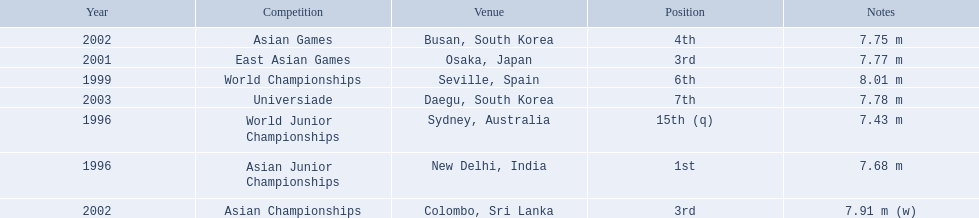Can you give me this table in json format? {'header': ['Year', 'Competition', 'Venue', 'Position', 'Notes'], 'rows': [['2002', 'Asian Games', 'Busan, South Korea', '4th', '7.75 m'], ['2001', 'East Asian Games', 'Osaka, Japan', '3rd', '7.77 m'], ['1999', 'World Championships', 'Seville, Spain', '6th', '8.01 m'], ['2003', 'Universiade', 'Daegu, South Korea', '7th', '7.78 m'], ['1996', 'World Junior Championships', 'Sydney, Australia', '15th (q)', '7.43 m'], ['1996', 'Asian Junior Championships', 'New Delhi, India', '1st', '7.68 m'], ['2002', 'Asian Championships', 'Colombo, Sri Lanka', '3rd', '7.91 m (w)']]} What are all of the competitions? World Junior Championships, Asian Junior Championships, World Championships, East Asian Games, Asian Championships, Asian Games, Universiade. What was his positions in these competitions? 15th (q), 1st, 6th, 3rd, 3rd, 4th, 7th. And during which competition did he reach 1st place? Asian Junior Championships. What rankings has this competitor placed through the competitions? 15th (q), 1st, 6th, 3rd, 3rd, 4th, 7th. In which competition did the competitor place 1st? Asian Junior Championships. 